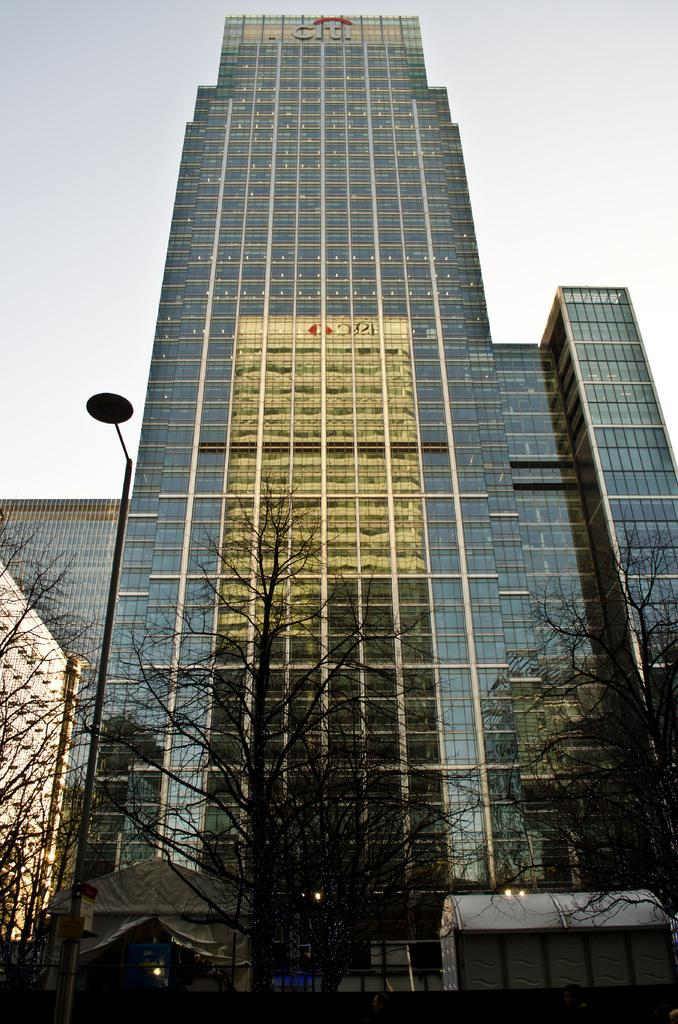What type of structure is visible in the image? There is a building in the image. What can be seen at the bottom of the image? Trees are present at the bottom of the image. Where is the pole located in the image? The pole is on the left side of the image. What is visible at the top of the image? The sky is visible at the top of the image. What type of meat is hanging from the pole in the image? There is no meat present in the image; the pole is on the left side of the building. 